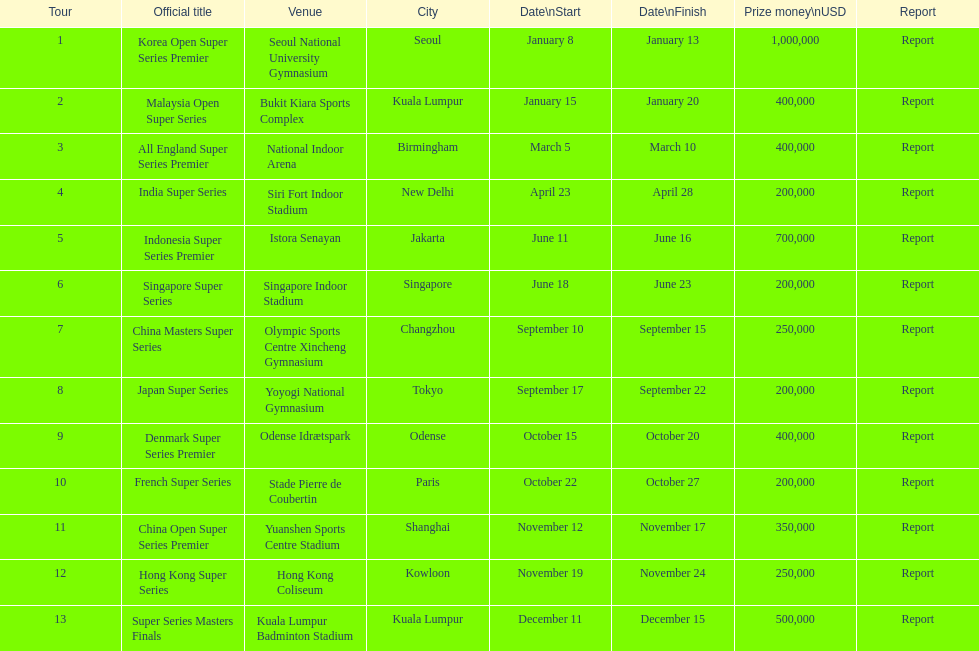For how long was the japan super series held? 5 days. 